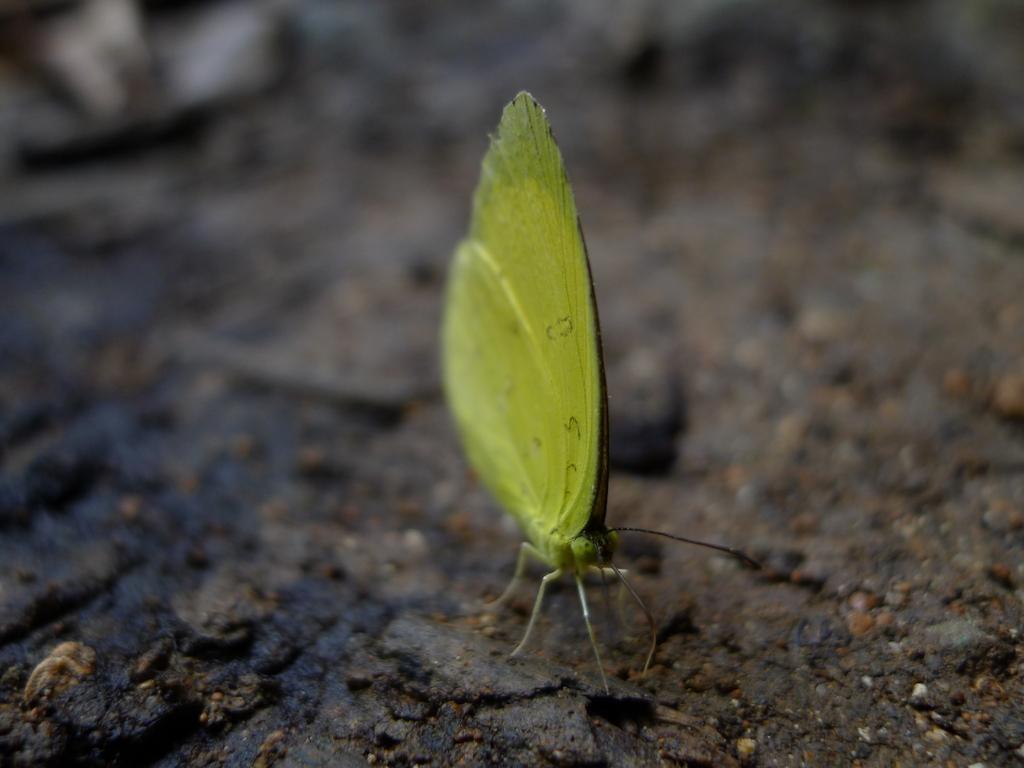How would you summarize this image in a sentence or two? In the picture there is a butterfly represent. 